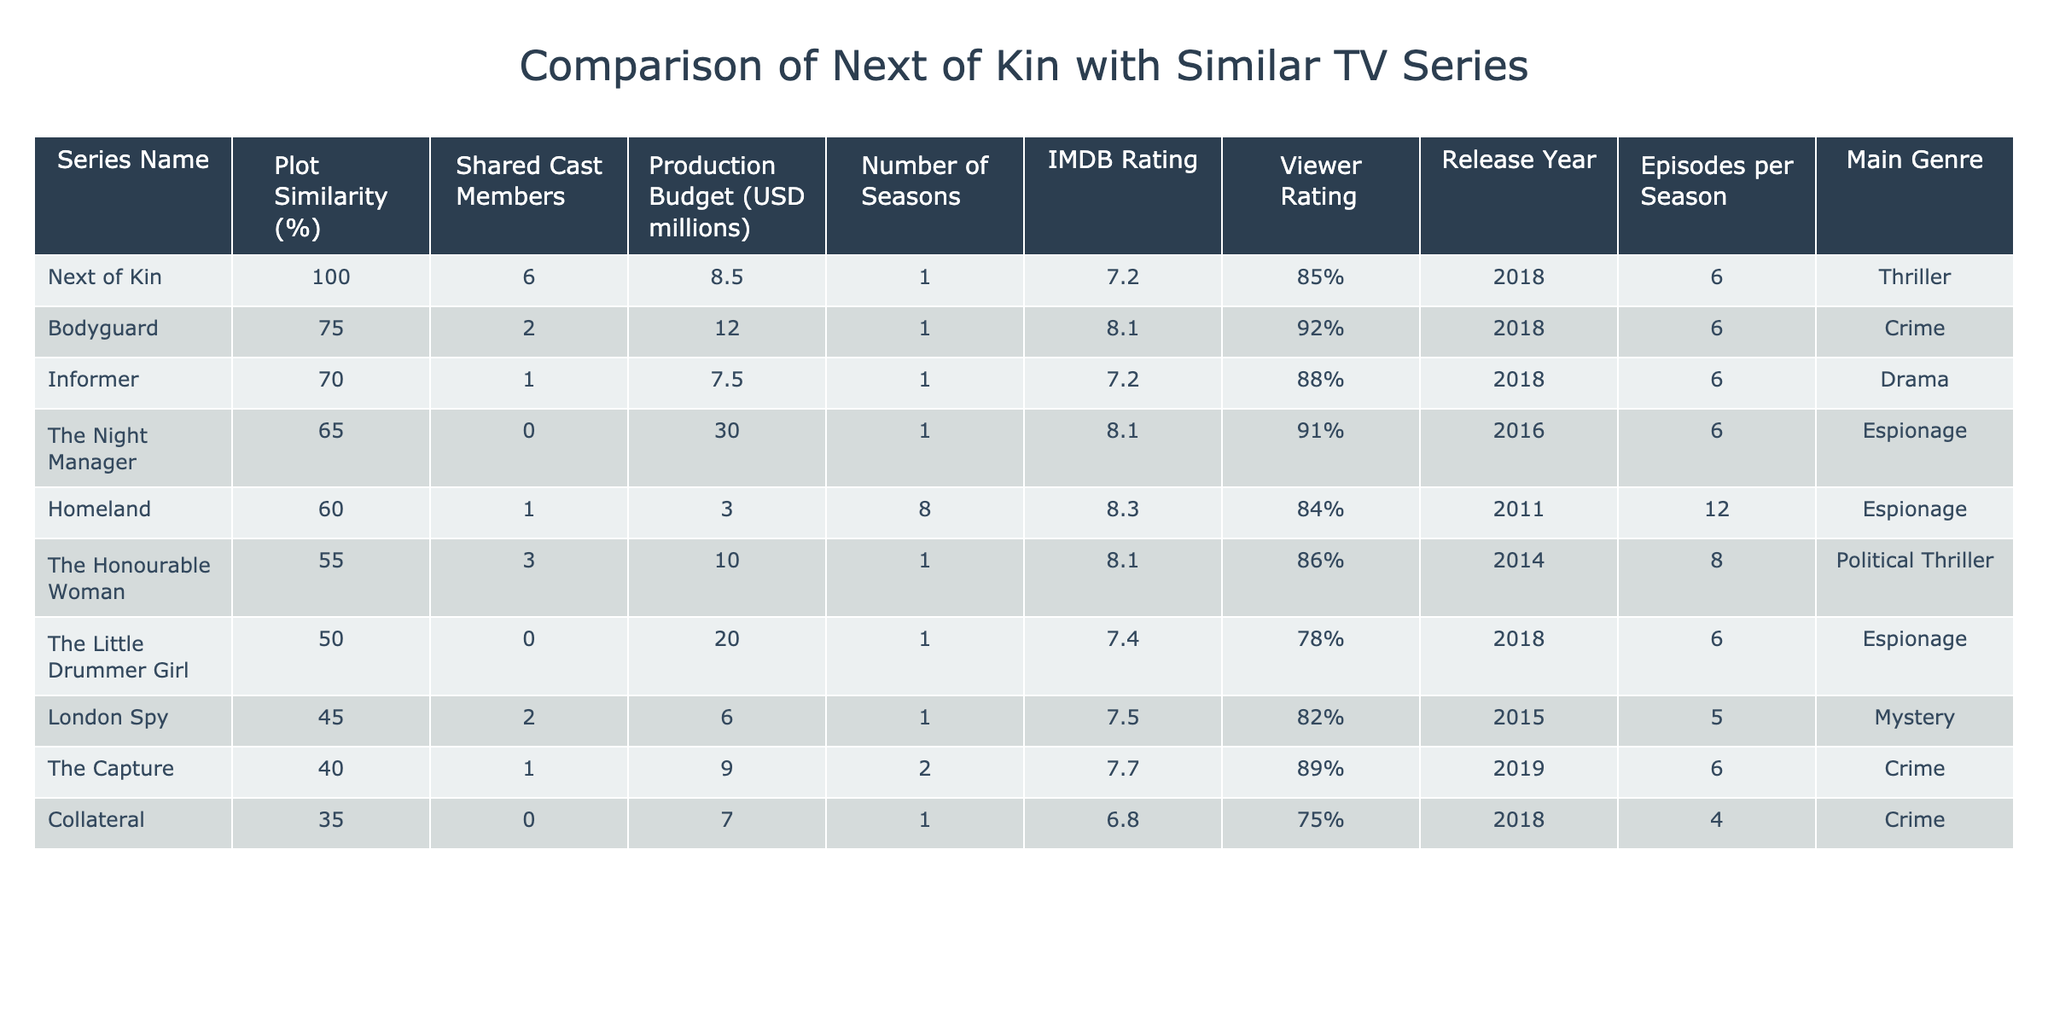What is the production budget of "Next of Kin"? The table shows that the production budget for "Next of Kin" is 8.5 million USD.
Answer: 8.5 million USD Which series has the highest IMDB rating? By comparing the IMDB ratings listed, "Homeland" has the highest rating of 8.3.
Answer: Homeland How many seasons does "Informer" have? The table indicates that "Informer" has a total of 1 season.
Answer: 1 season What is the average production budget of the series listed in the table? The production budgets are 8.5, 12, 7.5, 30, 3, 10, 20, 6, 9, 7. For a total of 10 series, the average is (8.5 + 12 + 7.5 + 30 + 3 + 10 + 20 + 6 + 9 + 7) / 10 = 6.7 million USD.
Answer: 6.7 million USD Does "Next of Kin" share cast members with "The Capture"? The table indicates that "Next of Kin" shares 6 cast members while "The Capture" shares 1 cast member, so they share cast members.
Answer: Yes Which series has the lowest viewer rating? Looking at the viewer ratings, "Collateral" has the lowest rating of 75%.
Answer: Collateral What is the difference in plot similarity percentage between "Next of Kin" and "Bodyguard"? The plot similarity for "Next of Kin" is 100% and for "Bodyguard" is 75%. The difference is 100 - 75 = 25%.
Answer: 25% How many episodes are there per season for "Homeland"? The table shows that "Homeland" has 12 episodes per season.
Answer: 12 episodes Which series has the most shared cast members with "Next of Kin"? The table indicates that "Next of Kin" shares 6 cast members with itself, which is the most.
Answer: Next of Kin How many total seasons do all the series combined have in the table? Summing the number of seasons: 1 + 1 + 1 + 1 + 8 + 1 + 1 + 1 + 1 + 2 = 18 total seasons across all series.
Answer: 18 seasons 